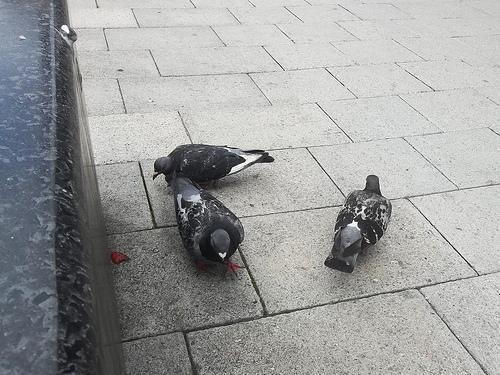How many birds are there?
Give a very brief answer. 3. 